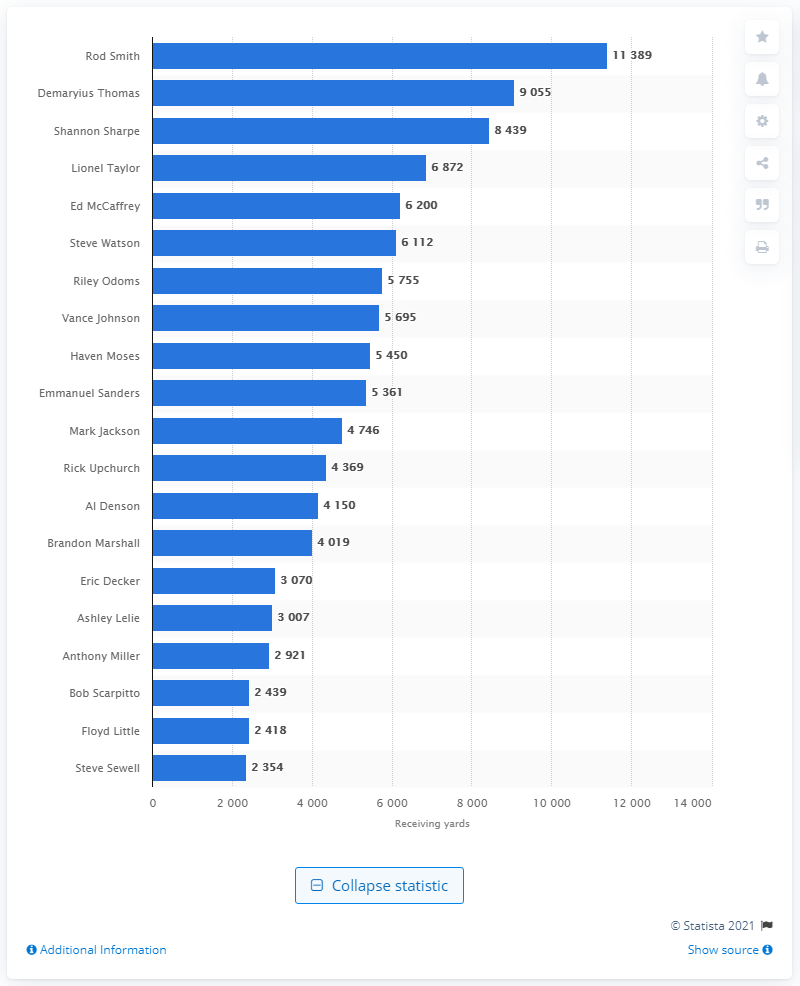Outline some significant characteristics in this image. Rod Smith is the all-time receiving leader for the Denver Broncos, with a remarkable total of career receptions. 